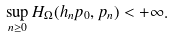<formula> <loc_0><loc_0><loc_500><loc_500>\sup _ { n \geq 0 } H _ { \Omega } ( h _ { n } p _ { 0 } , p _ { n } ) < + \infty .</formula> 